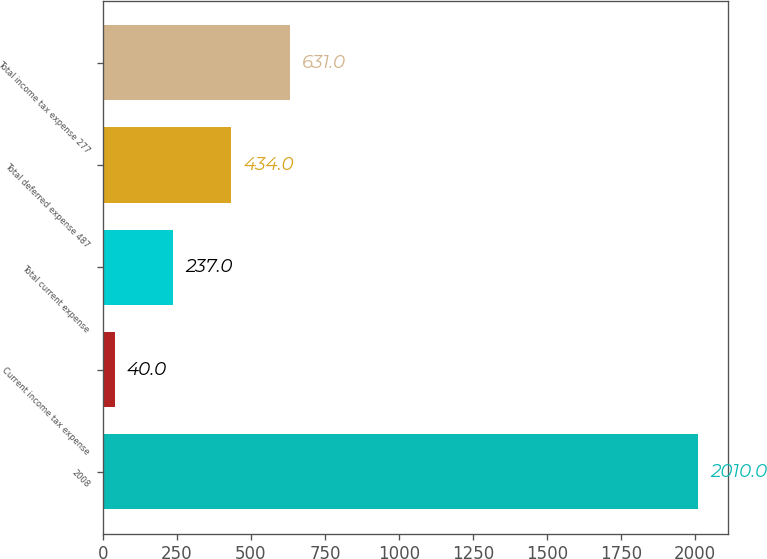Convert chart to OTSL. <chart><loc_0><loc_0><loc_500><loc_500><bar_chart><fcel>2008<fcel>Current income tax expense<fcel>Total current expense<fcel>Total deferred expense 487<fcel>Total income tax expense 277<nl><fcel>2010<fcel>40<fcel>237<fcel>434<fcel>631<nl></chart> 